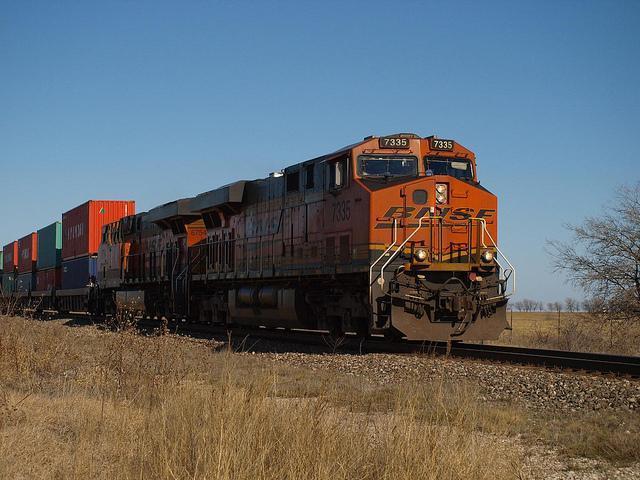How many lights are on the front of the train?
Give a very brief answer. 4. How many train tracks are there?
Give a very brief answer. 1. How many trains are shown?
Give a very brief answer. 1. How many trains are in the picture?
Give a very brief answer. 1. 